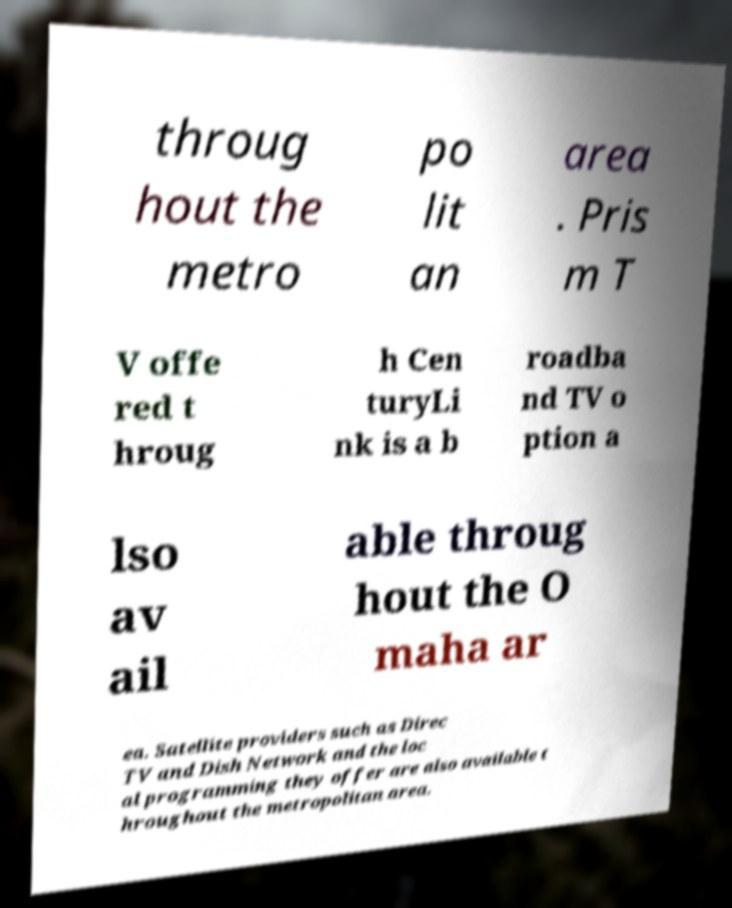What messages or text are displayed in this image? I need them in a readable, typed format. throug hout the metro po lit an area . Pris m T V offe red t hroug h Cen turyLi nk is a b roadba nd TV o ption a lso av ail able throug hout the O maha ar ea. Satellite providers such as Direc TV and Dish Network and the loc al programming they offer are also available t hroughout the metropolitan area. 